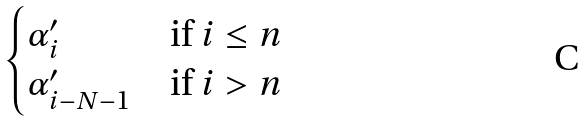<formula> <loc_0><loc_0><loc_500><loc_500>\begin{cases} \alpha ^ { \prime } _ { i } & \text {if } i \leq n \\ \alpha ^ { \prime } _ { i - N - 1 } & \text {if } i > n \end{cases}</formula> 